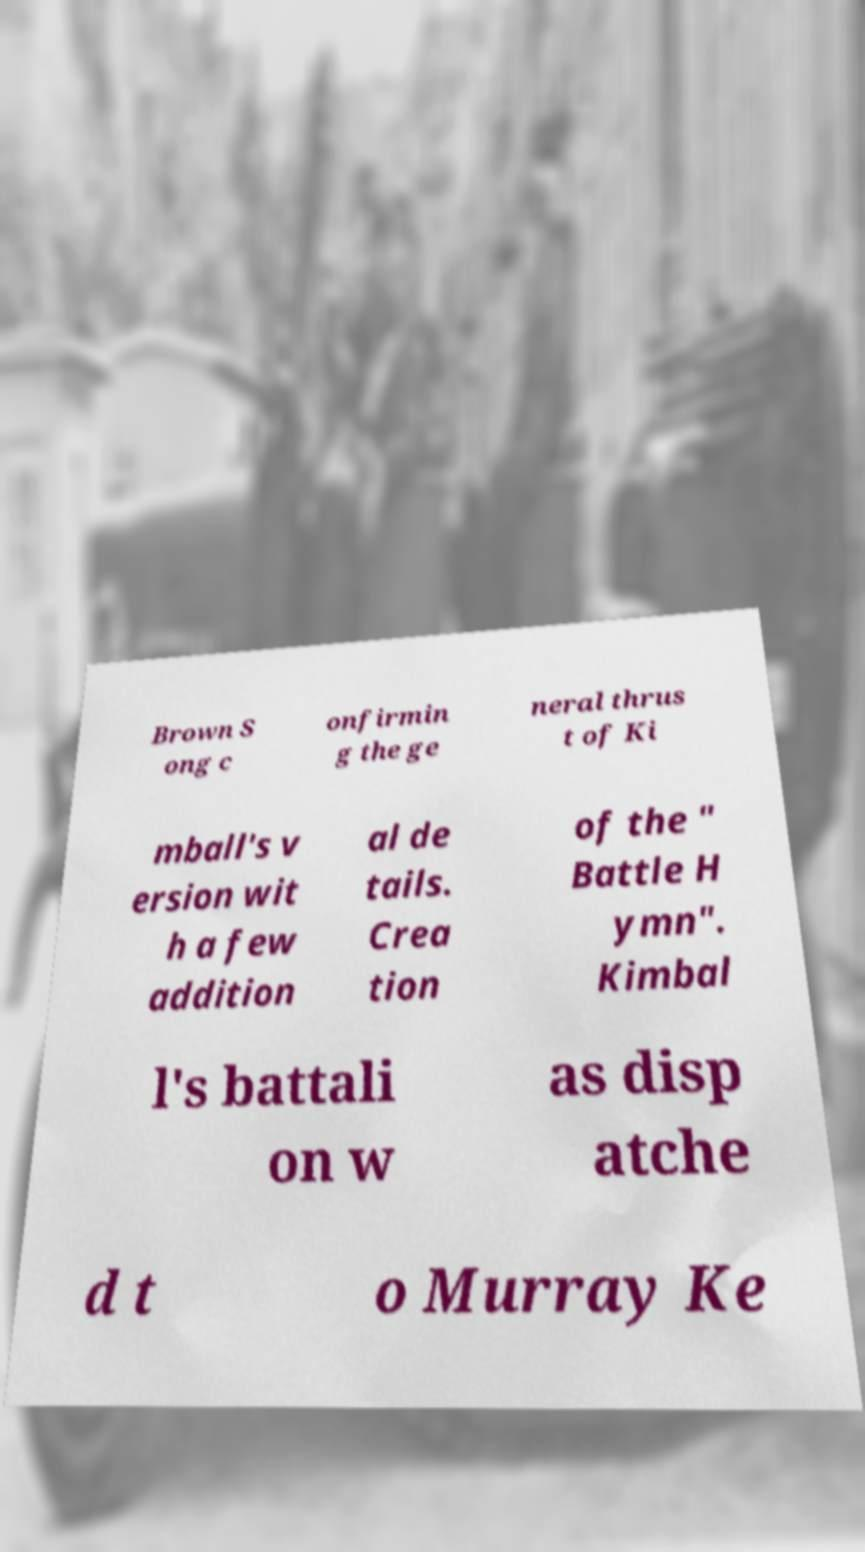For documentation purposes, I need the text within this image transcribed. Could you provide that? Brown S ong c onfirmin g the ge neral thrus t of Ki mball's v ersion wit h a few addition al de tails. Crea tion of the " Battle H ymn". Kimbal l's battali on w as disp atche d t o Murray Ke 